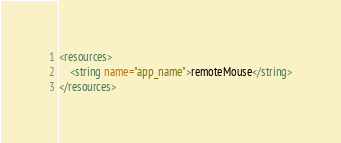Convert code to text. <code><loc_0><loc_0><loc_500><loc_500><_XML_><resources>
    <string name="app_name">remoteMouse</string>
</resources>
</code> 